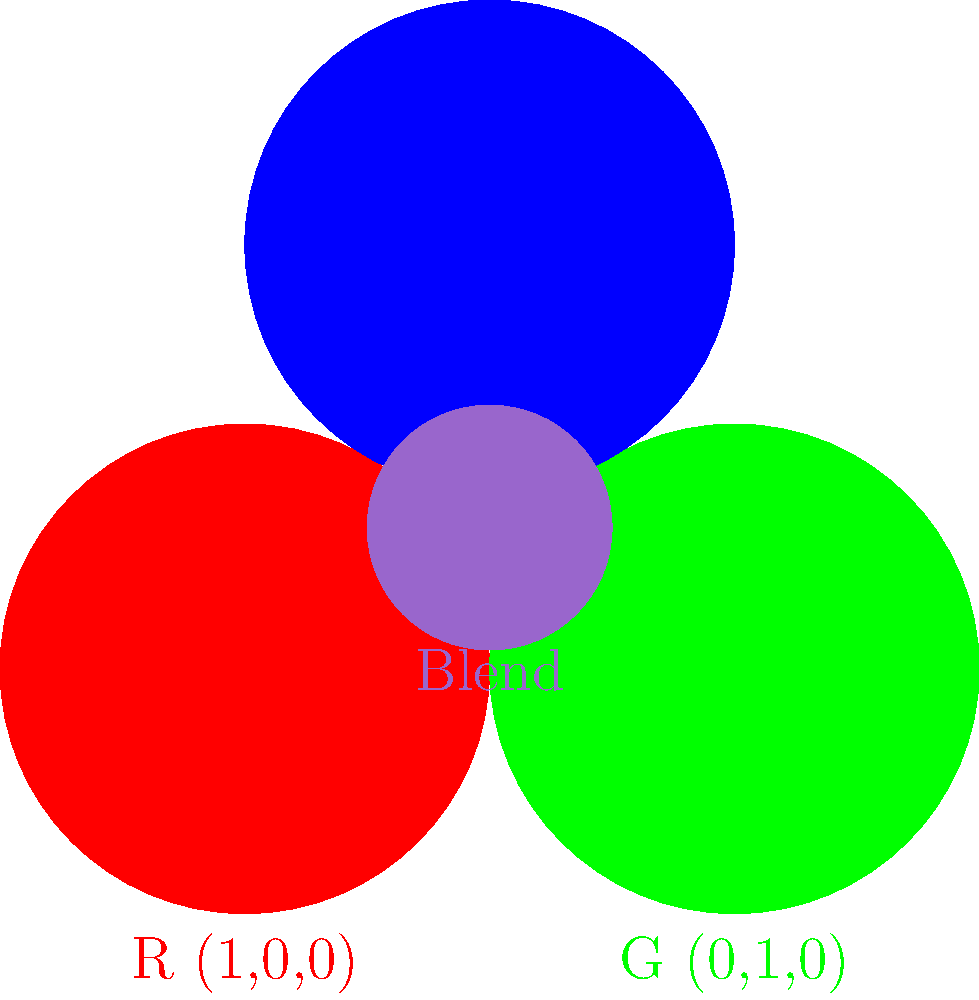In digital art, you're working on an anime character's magical aura. You want to create a unique purple hue by blending red, green, and blue colors. Given the RGB values in the diagram, what are the RGB values of the blended color in the center? To solve this problem, we need to analyze the RGB values of the blended color in the center of the diagram. Let's break it down step-by-step:

1. Observe the primary colors:
   - Red: $R = (1, 0, 0)$
   - Green: $G = (0, 1, 0)$
   - Blue: $B = (0, 0, 1)$

2. Look at the blended color in the center. We need to determine its RGB values.

3. In digital art, color blending often uses additive color mixing. The values for each channel (R, G, B) are added together and then normalized to a range of 0 to 1.

4. By examining the blended color, we can estimate its RGB values:
   - Red component: approximately 0.6
   - Green component: approximately 0.4
   - Blue component: approximately 0.8

5. Therefore, the RGB values of the blended color are $(0.6, 0.4, 0.8)$.

This combination creates a purple hue with a slight emphasis on the blue and red components, which is typical for magical aura effects in anime art.
Answer: $(0.6, 0.4, 0.8)$ 